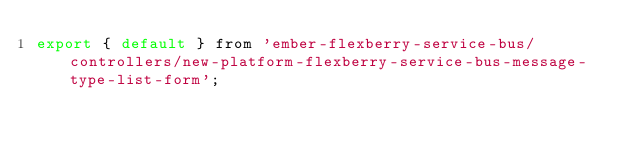Convert code to text. <code><loc_0><loc_0><loc_500><loc_500><_JavaScript_>export { default } from 'ember-flexberry-service-bus/controllers/new-platform-flexberry-service-bus-message-type-list-form';
</code> 